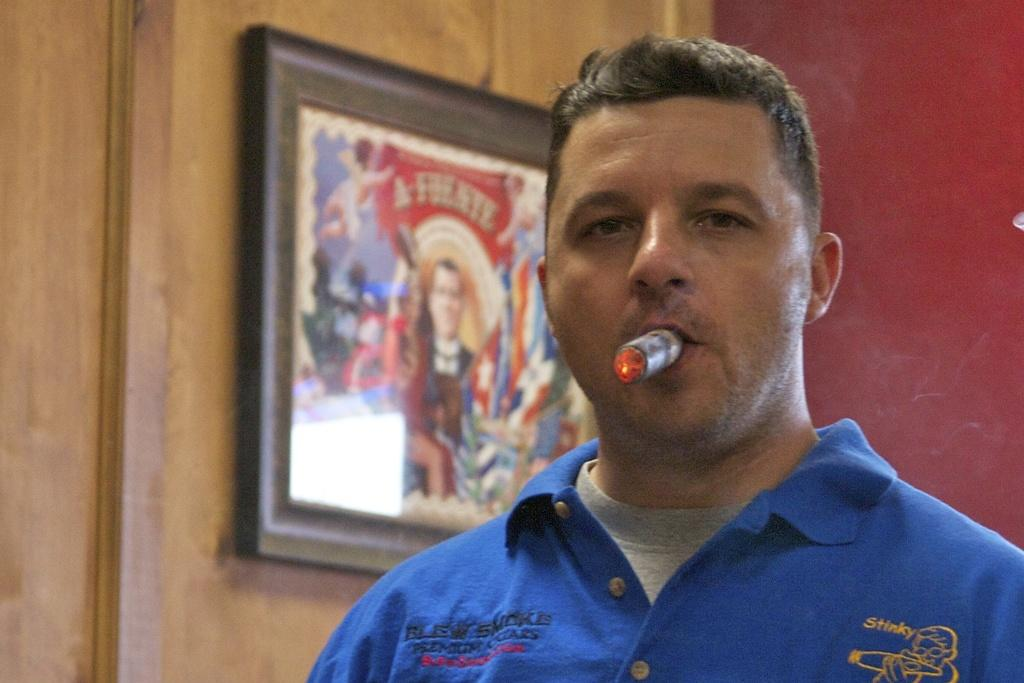What is on the wooden wall in the background of the image? There is a frame on the wooden wall in the background of the image. Who is present in the image? There is a man in the image. What is the man holding in his mouth? The man has a cigar in his mouth. What can be seen on the right side of the image? There is a wall on the right side of the image. How does the man trade his cigar for a different item in the image? There is no indication in the image that the man is trading his cigar for a different item. What is the temperature of the cigar in the image? The temperature of the cigar cannot be determined from the image. 